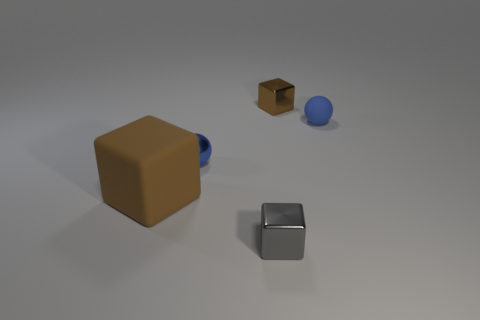How many things are either blue spheres or brown objects that are in front of the small matte object?
Make the answer very short. 3. There is a large brown thing that is the same shape as the gray shiny thing; what is its material?
Provide a short and direct response. Rubber. Do the matte object behind the large brown block and the brown shiny thing have the same shape?
Give a very brief answer. No. Is there any other thing that has the same size as the matte block?
Offer a terse response. No. Are there fewer small brown things left of the gray object than metallic blocks that are to the right of the big rubber cube?
Give a very brief answer. Yes. What number of other things are there of the same shape as the big brown matte thing?
Your response must be concise. 2. There is a brown cube in front of the tiny blue object to the left of the small sphere to the right of the small blue shiny ball; what is its size?
Offer a terse response. Large. What number of brown objects are either blocks or big cubes?
Your response must be concise. 2. There is a small shiny object that is behind the sphere behind the tiny metal sphere; what is its shape?
Give a very brief answer. Cube. Does the rubber thing that is on the right side of the tiny gray metal cube have the same size as the blue thing to the left of the tiny rubber ball?
Make the answer very short. Yes. 